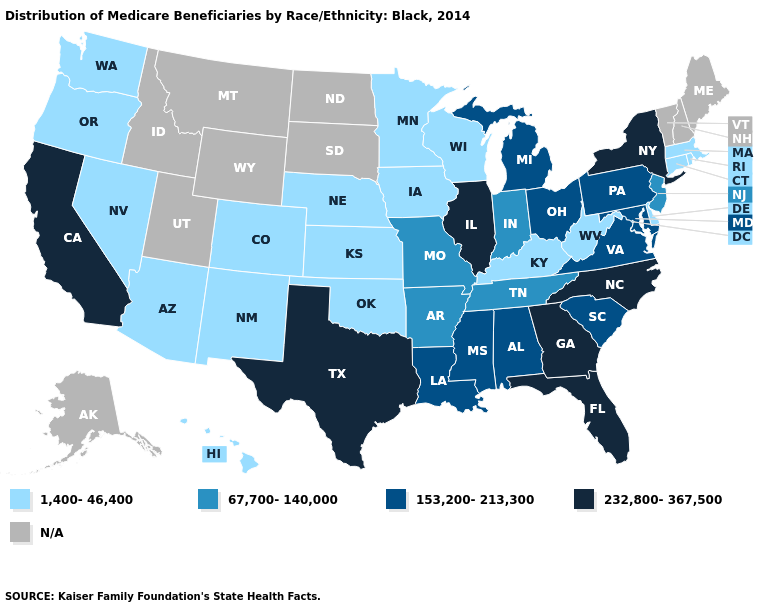Which states hav the highest value in the MidWest?
Short answer required. Illinois. Name the states that have a value in the range 232,800-367,500?
Concise answer only. California, Florida, Georgia, Illinois, New York, North Carolina, Texas. Which states have the lowest value in the USA?
Keep it brief. Arizona, Colorado, Connecticut, Delaware, Hawaii, Iowa, Kansas, Kentucky, Massachusetts, Minnesota, Nebraska, Nevada, New Mexico, Oklahoma, Oregon, Rhode Island, Washington, West Virginia, Wisconsin. Name the states that have a value in the range 232,800-367,500?
Keep it brief. California, Florida, Georgia, Illinois, New York, North Carolina, Texas. Does Pennsylvania have the highest value in the USA?
Be succinct. No. What is the value of North Carolina?
Concise answer only. 232,800-367,500. Among the states that border Tennessee , does Kentucky have the lowest value?
Short answer required. Yes. Among the states that border Michigan , which have the lowest value?
Answer briefly. Wisconsin. What is the value of Michigan?
Keep it brief. 153,200-213,300. Name the states that have a value in the range 153,200-213,300?
Concise answer only. Alabama, Louisiana, Maryland, Michigan, Mississippi, Ohio, Pennsylvania, South Carolina, Virginia. What is the value of Arizona?
Be succinct. 1,400-46,400. Name the states that have a value in the range 232,800-367,500?
Be succinct. California, Florida, Georgia, Illinois, New York, North Carolina, Texas. Which states have the highest value in the USA?
Concise answer only. California, Florida, Georgia, Illinois, New York, North Carolina, Texas. Does California have the highest value in the USA?
Concise answer only. Yes. What is the value of Louisiana?
Short answer required. 153,200-213,300. 